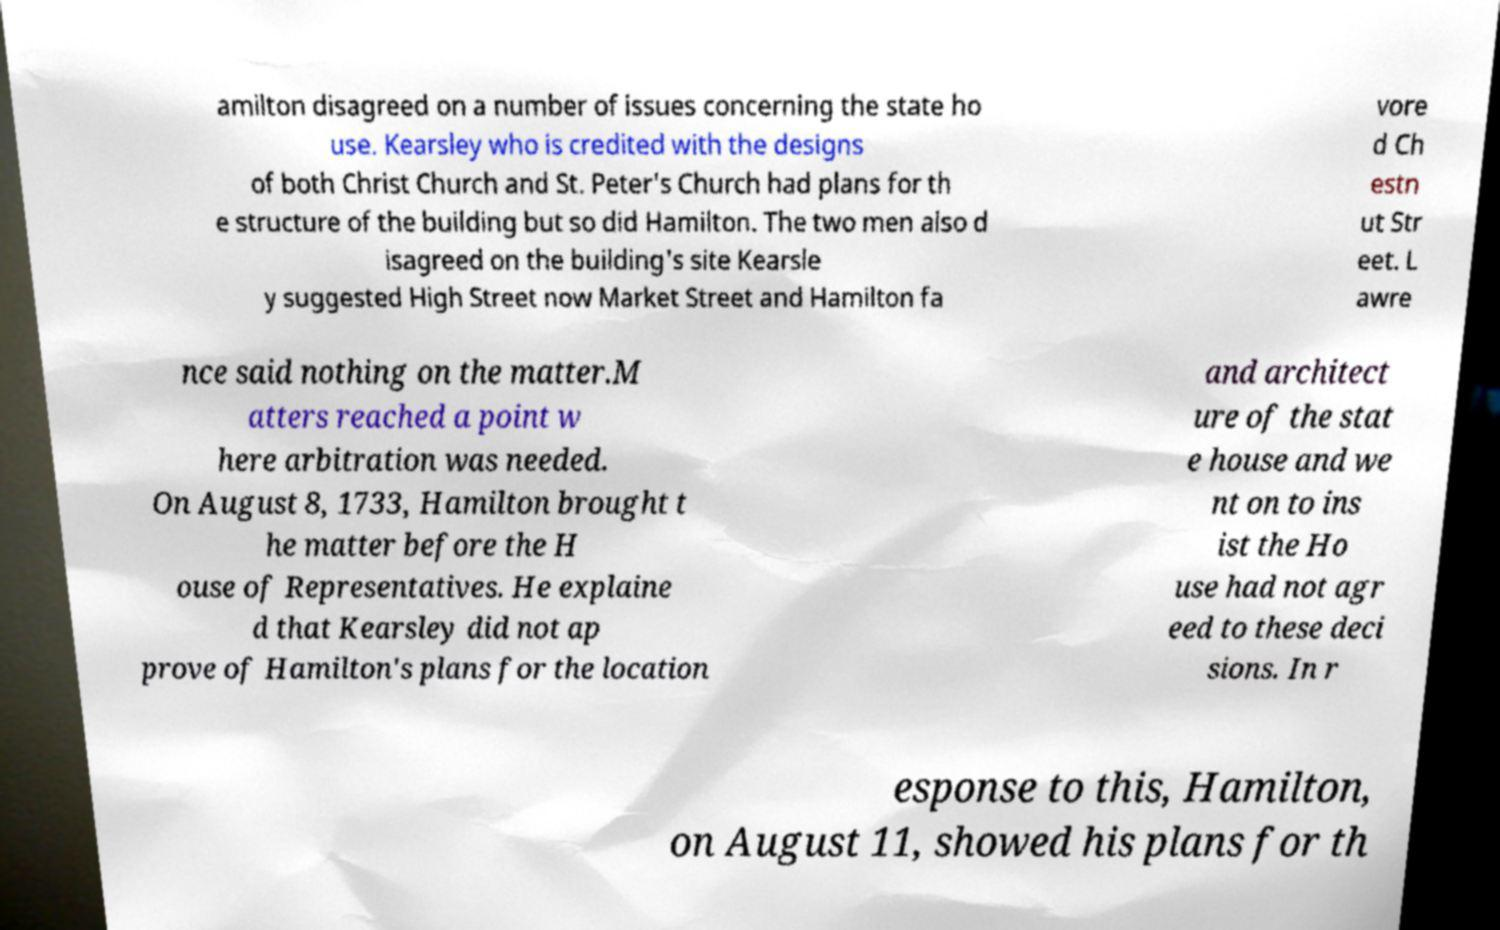What messages or text are displayed in this image? I need them in a readable, typed format. amilton disagreed on a number of issues concerning the state ho use. Kearsley who is credited with the designs of both Christ Church and St. Peter's Church had plans for th e structure of the building but so did Hamilton. The two men also d isagreed on the building's site Kearsle y suggested High Street now Market Street and Hamilton fa vore d Ch estn ut Str eet. L awre nce said nothing on the matter.M atters reached a point w here arbitration was needed. On August 8, 1733, Hamilton brought t he matter before the H ouse of Representatives. He explaine d that Kearsley did not ap prove of Hamilton's plans for the location and architect ure of the stat e house and we nt on to ins ist the Ho use had not agr eed to these deci sions. In r esponse to this, Hamilton, on August 11, showed his plans for th 